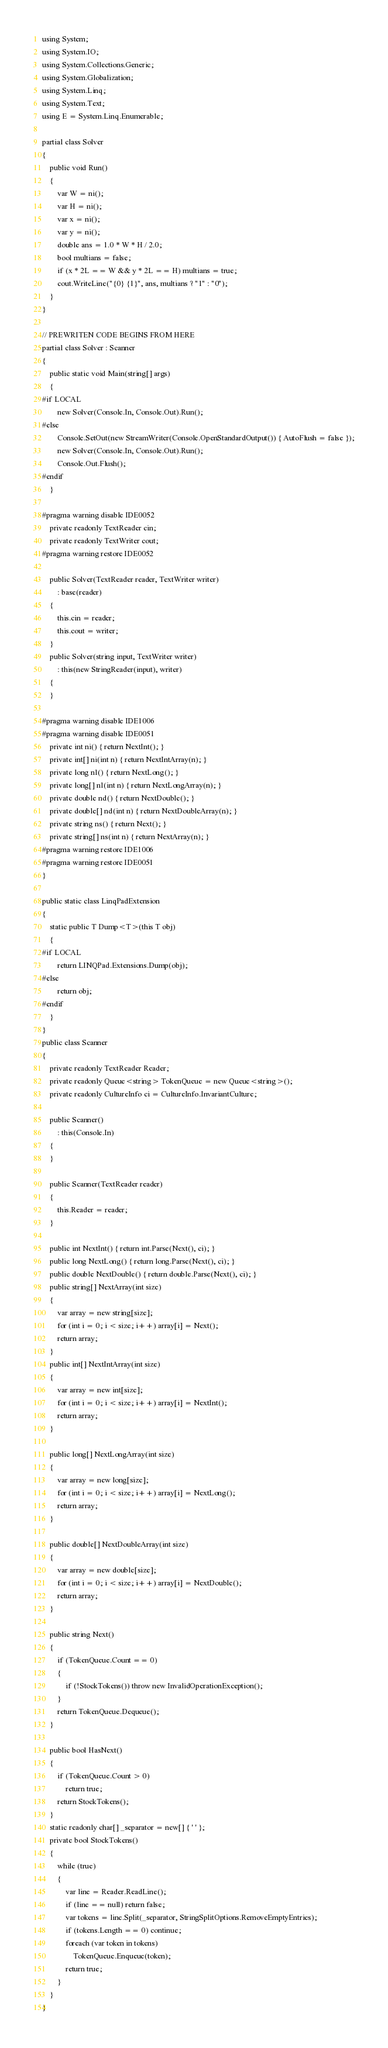Convert code to text. <code><loc_0><loc_0><loc_500><loc_500><_C#_>using System;
using System.IO;
using System.Collections.Generic;
using System.Globalization;
using System.Linq;
using System.Text;
using E = System.Linq.Enumerable;

partial class Solver
{
    public void Run()
    {
        var W = ni();
        var H = ni();
        var x = ni();
        var y = ni();
        double ans = 1.0 * W * H / 2.0;
        bool multians = false;
        if (x * 2L == W && y * 2L == H) multians = true;
        cout.WriteLine("{0} {1}", ans, multians ? "1" : "0");
    }
}

// PREWRITEN CODE BEGINS FROM HERE
partial class Solver : Scanner
{
    public static void Main(string[] args)
    {
#if LOCAL
        new Solver(Console.In, Console.Out).Run();
#else
        Console.SetOut(new StreamWriter(Console.OpenStandardOutput()) { AutoFlush = false });
        new Solver(Console.In, Console.Out).Run();
        Console.Out.Flush();
#endif
    }

#pragma warning disable IDE0052
    private readonly TextReader cin;
    private readonly TextWriter cout;
#pragma warning restore IDE0052

    public Solver(TextReader reader, TextWriter writer)
        : base(reader)
    {
        this.cin = reader;
        this.cout = writer;
    }
    public Solver(string input, TextWriter writer)
        : this(new StringReader(input), writer)
    {
    }

#pragma warning disable IDE1006
#pragma warning disable IDE0051
    private int ni() { return NextInt(); }
    private int[] ni(int n) { return NextIntArray(n); }
    private long nl() { return NextLong(); }
    private long[] nl(int n) { return NextLongArray(n); }
    private double nd() { return NextDouble(); }
    private double[] nd(int n) { return NextDoubleArray(n); }
    private string ns() { return Next(); }
    private string[] ns(int n) { return NextArray(n); }
#pragma warning restore IDE1006
#pragma warning restore IDE0051
}

public static class LinqPadExtension
{
    static public T Dump<T>(this T obj)
    {
#if LOCAL
        return LINQPad.Extensions.Dump(obj);
#else
        return obj;
#endif
    }
}
public class Scanner
{
    private readonly TextReader Reader;
    private readonly Queue<string> TokenQueue = new Queue<string>();
    private readonly CultureInfo ci = CultureInfo.InvariantCulture;

    public Scanner()
        : this(Console.In)
    {
    }

    public Scanner(TextReader reader)
    {
        this.Reader = reader;
    }

    public int NextInt() { return int.Parse(Next(), ci); }
    public long NextLong() { return long.Parse(Next(), ci); }
    public double NextDouble() { return double.Parse(Next(), ci); }
    public string[] NextArray(int size)
    {
        var array = new string[size];
        for (int i = 0; i < size; i++) array[i] = Next();
        return array;
    }
    public int[] NextIntArray(int size)
    {
        var array = new int[size];
        for (int i = 0; i < size; i++) array[i] = NextInt();
        return array;
    }

    public long[] NextLongArray(int size)
    {
        var array = new long[size];
        for (int i = 0; i < size; i++) array[i] = NextLong();
        return array;
    }

    public double[] NextDoubleArray(int size)
    {
        var array = new double[size];
        for (int i = 0; i < size; i++) array[i] = NextDouble();
        return array;
    }

    public string Next()
    {
        if (TokenQueue.Count == 0)
        {
            if (!StockTokens()) throw new InvalidOperationException();
        }
        return TokenQueue.Dequeue();
    }

    public bool HasNext()
    {
        if (TokenQueue.Count > 0)
            return true;
        return StockTokens();
    }
    static readonly char[] _separator = new[] { ' ' };
    private bool StockTokens()
    {
        while (true)
        {
            var line = Reader.ReadLine();
            if (line == null) return false;
            var tokens = line.Split(_separator, StringSplitOptions.RemoveEmptyEntries);
            if (tokens.Length == 0) continue;
            foreach (var token in tokens)
                TokenQueue.Enqueue(token);
            return true;
        }
    }
}
</code> 